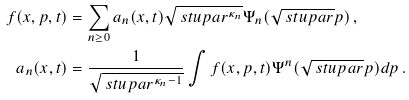Convert formula to latex. <formula><loc_0><loc_0><loc_500><loc_500>f ( x , p , t ) & = \sum _ { n \geq 0 } a _ { n } ( x , t ) \sqrt { \ s t u p a r ^ { \kappa _ { n } } } \Psi _ { n } ( \sqrt { \ s t u p a r } p ) \, , \\ a _ { n } ( x , t ) & = \frac { 1 } { \sqrt { \ s t u p a r ^ { \kappa _ { n } - 1 } } } \int f ( x , p , t ) \Psi ^ { n } ( \sqrt { \ s t u p a r } p ) d p \, .</formula> 